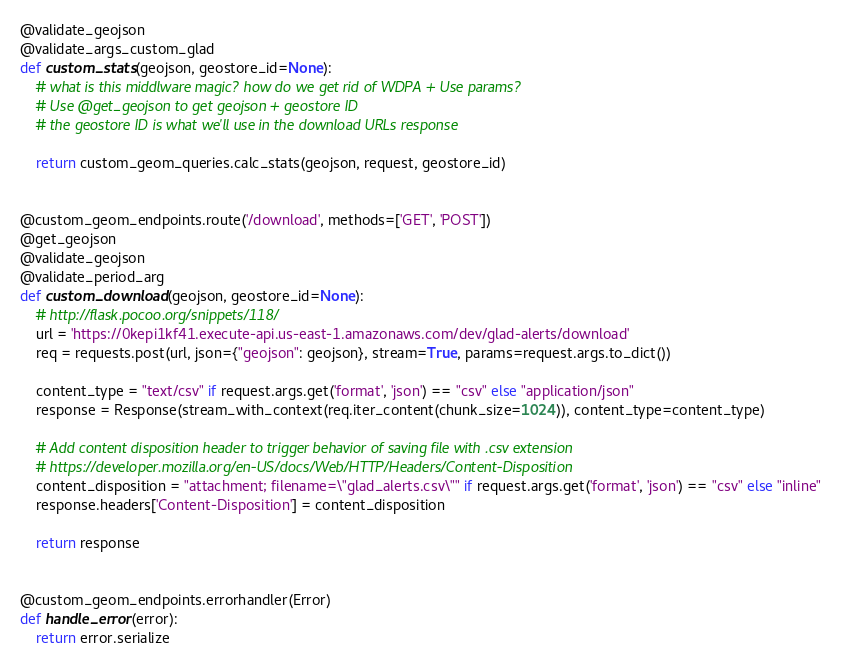Convert code to text. <code><loc_0><loc_0><loc_500><loc_500><_Python_>@validate_geojson
@validate_args_custom_glad
def custom_stats(geojson, geostore_id=None):
    # what is this middlware magic? how do we get rid of WDPA + Use params?
    # Use @get_geojson to get geojson + geostore ID
    # the geostore ID is what we'll use in the download URLs response

    return custom_geom_queries.calc_stats(geojson, request, geostore_id)


@custom_geom_endpoints.route('/download', methods=['GET', 'POST'])
@get_geojson
@validate_geojson
@validate_period_arg
def custom_download(geojson, geostore_id=None):
    # http://flask.pocoo.org/snippets/118/
    url = 'https://0kepi1kf41.execute-api.us-east-1.amazonaws.com/dev/glad-alerts/download'
    req = requests.post(url, json={"geojson": geojson}, stream=True, params=request.args.to_dict())

    content_type = "text/csv" if request.args.get('format', 'json') == "csv" else "application/json"
    response = Response(stream_with_context(req.iter_content(chunk_size=1024)), content_type=content_type)
    
    # Add content disposition header to trigger behavior of saving file with .csv extension
    # https://developer.mozilla.org/en-US/docs/Web/HTTP/Headers/Content-Disposition
    content_disposition = "attachment; filename=\"glad_alerts.csv\"" if request.args.get('format', 'json') == "csv" else "inline"
    response.headers['Content-Disposition'] = content_disposition

    return response


@custom_geom_endpoints.errorhandler(Error)
def handle_error(error):
    return error.serialize
</code> 